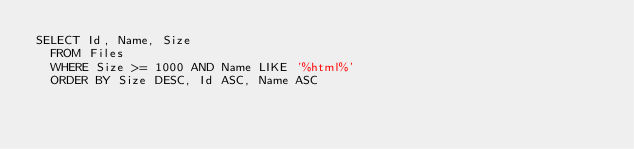Convert code to text. <code><loc_0><loc_0><loc_500><loc_500><_SQL_>SELECT Id, Name, Size
	FROM Files
	WHERE Size >= 1000 AND Name LIKE '%html%'
	ORDER BY Size DESC, Id ASC, Name ASC</code> 